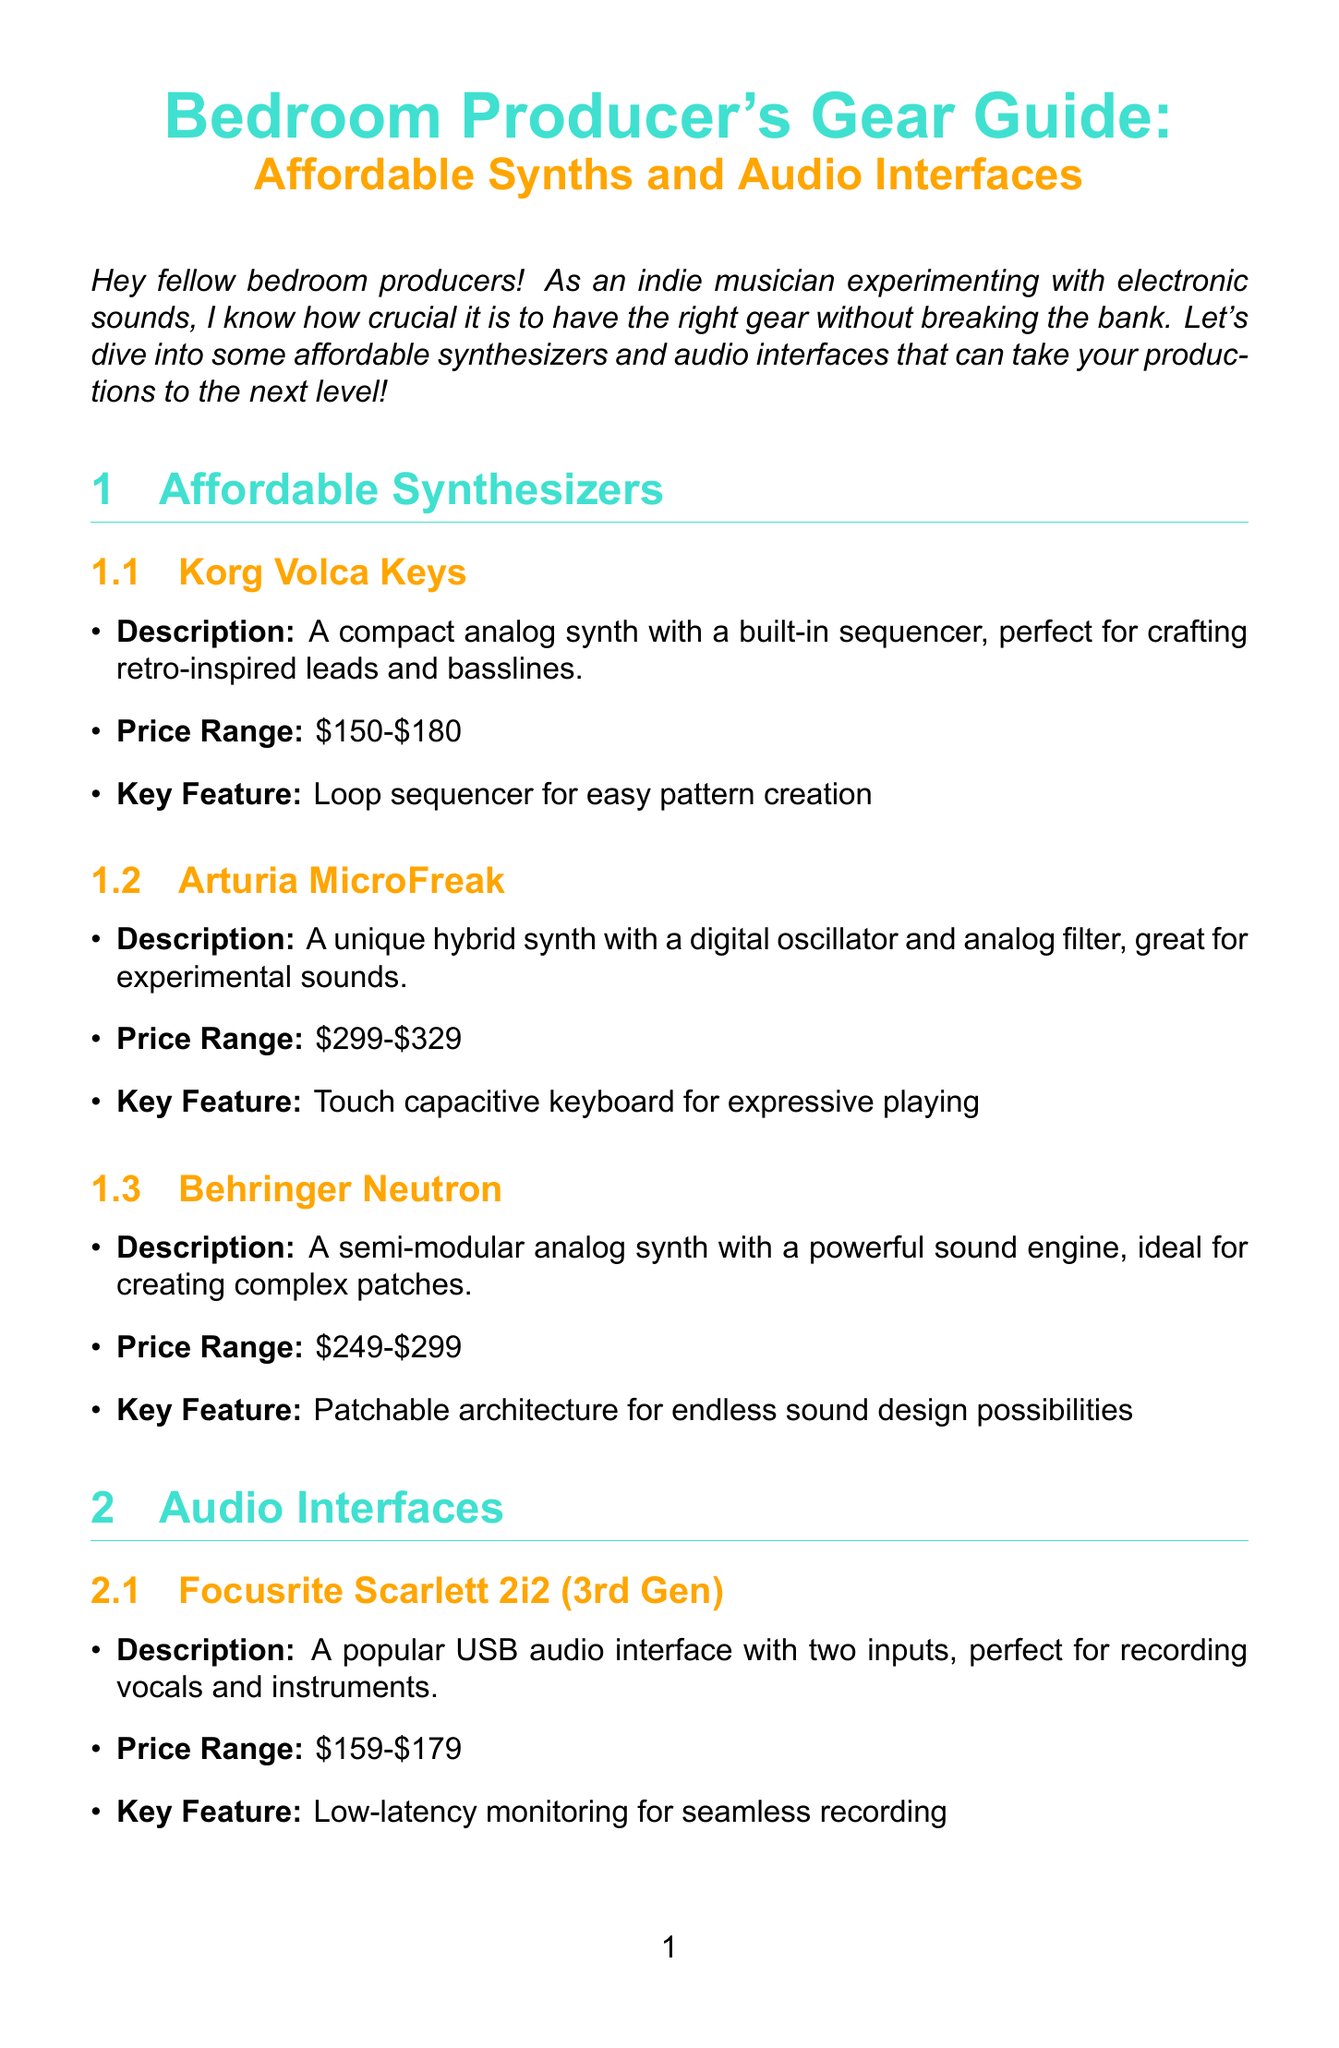What is the title of the newsletter? The title of the newsletter is prominently displayed at the beginning, stating the focus on affordable synthesizers and audio interfaces.
Answer: Bedroom Producer's Gear Guide: Affordable Synths and Audio Interfaces What is the price range for the Korg Volca Keys? The price range for the Korg Volca Keys is mentioned in the section detailing affordable synthesizers.
Answer: $150-$180 What unique feature does the Arturia MicroFreak have? The unique feature of the Arturia MicroFreak is highlighted under its specifications in the document.
Answer: Touch capacitive keyboard for expressive playing Which audio interface is priced between $159 and $179? The document lists various audio interfaces along with their price ranges, and this specific range indicates one of them.
Answer: Focusrite Scarlett 2i2 (3rd Gen) What is the primary focus of this newsletter? The introduction outlines the main goal of the newsletter, specifically aimed at bedroom producers looking for budget-friendly gear.
Answer: Affordable synthesizers and audio interfaces Which social media platform is recommended for sharing gear setups? The social media tips provide guidance on where to share setups to connect with other musicians.
Answer: Instagram How many synthesizers are mentioned in the document? The document lists the number of synthesizers included in the affordable synthesizers section.
Answer: Three What is the key feature of Behringer U-Phoria UMC204HD? The document specifies the distinct features of the listed audio interfaces, including this one.
Answer: MIDAS-designed preamps for clear, professional sound What does the newsletter remind readers about gear? The conclusion emphasizes an important perspective regarding music production, reinforcing the creative aspect over material possessions.
Answer: Gear is just a tool – your creativity is what truly matters 